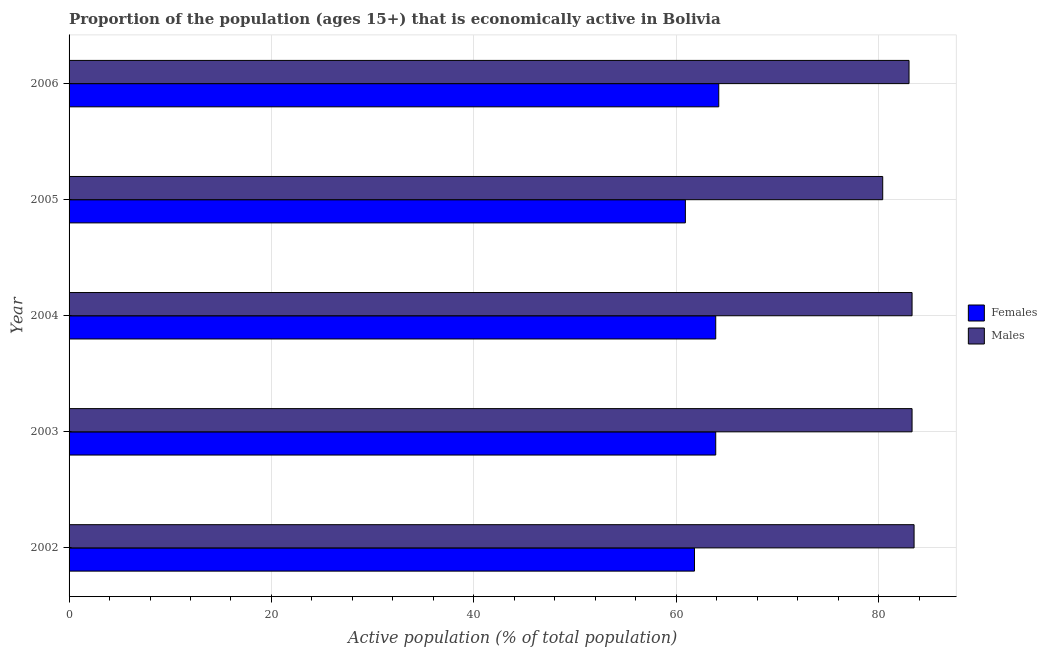How many groups of bars are there?
Provide a short and direct response. 5. What is the percentage of economically active female population in 2005?
Give a very brief answer. 60.9. Across all years, what is the maximum percentage of economically active male population?
Make the answer very short. 83.5. Across all years, what is the minimum percentage of economically active male population?
Your response must be concise. 80.4. In which year was the percentage of economically active male population maximum?
Provide a succinct answer. 2002. In which year was the percentage of economically active female population minimum?
Provide a short and direct response. 2005. What is the total percentage of economically active female population in the graph?
Ensure brevity in your answer.  314.7. What is the difference between the percentage of economically active male population in 2002 and that in 2003?
Your answer should be compact. 0.2. What is the difference between the percentage of economically active male population in 2002 and the percentage of economically active female population in 2003?
Offer a very short reply. 19.6. What is the average percentage of economically active male population per year?
Provide a short and direct response. 82.7. Is the percentage of economically active female population in 2002 less than that in 2004?
Provide a short and direct response. Yes. Is the difference between the percentage of economically active female population in 2002 and 2006 greater than the difference between the percentage of economically active male population in 2002 and 2006?
Provide a short and direct response. No. What is the difference between the highest and the second highest percentage of economically active male population?
Give a very brief answer. 0.2. In how many years, is the percentage of economically active female population greater than the average percentage of economically active female population taken over all years?
Make the answer very short. 3. What does the 1st bar from the top in 2004 represents?
Make the answer very short. Males. What does the 1st bar from the bottom in 2004 represents?
Your answer should be very brief. Females. How many bars are there?
Make the answer very short. 10. Are all the bars in the graph horizontal?
Your answer should be very brief. Yes. How many years are there in the graph?
Offer a terse response. 5. Does the graph contain any zero values?
Give a very brief answer. No. Does the graph contain grids?
Give a very brief answer. Yes. Where does the legend appear in the graph?
Your answer should be compact. Center right. How many legend labels are there?
Ensure brevity in your answer.  2. What is the title of the graph?
Offer a terse response. Proportion of the population (ages 15+) that is economically active in Bolivia. Does "Goods" appear as one of the legend labels in the graph?
Keep it short and to the point. No. What is the label or title of the X-axis?
Keep it short and to the point. Active population (% of total population). What is the Active population (% of total population) in Females in 2002?
Give a very brief answer. 61.8. What is the Active population (% of total population) of Males in 2002?
Make the answer very short. 83.5. What is the Active population (% of total population) in Females in 2003?
Your response must be concise. 63.9. What is the Active population (% of total population) of Males in 2003?
Provide a short and direct response. 83.3. What is the Active population (% of total population) in Females in 2004?
Give a very brief answer. 63.9. What is the Active population (% of total population) in Males in 2004?
Your answer should be compact. 83.3. What is the Active population (% of total population) of Females in 2005?
Make the answer very short. 60.9. What is the Active population (% of total population) in Males in 2005?
Your response must be concise. 80.4. What is the Active population (% of total population) of Females in 2006?
Keep it short and to the point. 64.2. Across all years, what is the maximum Active population (% of total population) of Females?
Your answer should be compact. 64.2. Across all years, what is the maximum Active population (% of total population) in Males?
Provide a succinct answer. 83.5. Across all years, what is the minimum Active population (% of total population) of Females?
Keep it short and to the point. 60.9. Across all years, what is the minimum Active population (% of total population) in Males?
Your answer should be very brief. 80.4. What is the total Active population (% of total population) in Females in the graph?
Offer a very short reply. 314.7. What is the total Active population (% of total population) of Males in the graph?
Ensure brevity in your answer.  413.5. What is the difference between the Active population (% of total population) of Females in 2002 and that in 2003?
Make the answer very short. -2.1. What is the difference between the Active population (% of total population) of Males in 2002 and that in 2003?
Give a very brief answer. 0.2. What is the difference between the Active population (% of total population) in Females in 2002 and that in 2004?
Ensure brevity in your answer.  -2.1. What is the difference between the Active population (% of total population) of Males in 2002 and that in 2004?
Your response must be concise. 0.2. What is the difference between the Active population (% of total population) of Females in 2002 and that in 2005?
Ensure brevity in your answer.  0.9. What is the difference between the Active population (% of total population) in Males in 2002 and that in 2005?
Your answer should be very brief. 3.1. What is the difference between the Active population (% of total population) in Females in 2002 and that in 2006?
Offer a terse response. -2.4. What is the difference between the Active population (% of total population) of Females in 2003 and that in 2005?
Make the answer very short. 3. What is the difference between the Active population (% of total population) in Females in 2004 and that in 2005?
Your answer should be compact. 3. What is the difference between the Active population (% of total population) of Males in 2004 and that in 2006?
Make the answer very short. 0.3. What is the difference between the Active population (% of total population) in Females in 2002 and the Active population (% of total population) in Males in 2003?
Ensure brevity in your answer.  -21.5. What is the difference between the Active population (% of total population) of Females in 2002 and the Active population (% of total population) of Males in 2004?
Give a very brief answer. -21.5. What is the difference between the Active population (% of total population) in Females in 2002 and the Active population (% of total population) in Males in 2005?
Your answer should be compact. -18.6. What is the difference between the Active population (% of total population) of Females in 2002 and the Active population (% of total population) of Males in 2006?
Provide a short and direct response. -21.2. What is the difference between the Active population (% of total population) of Females in 2003 and the Active population (% of total population) of Males in 2004?
Your answer should be very brief. -19.4. What is the difference between the Active population (% of total population) in Females in 2003 and the Active population (% of total population) in Males in 2005?
Provide a succinct answer. -16.5. What is the difference between the Active population (% of total population) of Females in 2003 and the Active population (% of total population) of Males in 2006?
Your answer should be compact. -19.1. What is the difference between the Active population (% of total population) of Females in 2004 and the Active population (% of total population) of Males in 2005?
Offer a very short reply. -16.5. What is the difference between the Active population (% of total population) in Females in 2004 and the Active population (% of total population) in Males in 2006?
Your answer should be very brief. -19.1. What is the difference between the Active population (% of total population) of Females in 2005 and the Active population (% of total population) of Males in 2006?
Offer a terse response. -22.1. What is the average Active population (% of total population) of Females per year?
Your answer should be compact. 62.94. What is the average Active population (% of total population) in Males per year?
Provide a short and direct response. 82.7. In the year 2002, what is the difference between the Active population (% of total population) in Females and Active population (% of total population) in Males?
Provide a succinct answer. -21.7. In the year 2003, what is the difference between the Active population (% of total population) of Females and Active population (% of total population) of Males?
Give a very brief answer. -19.4. In the year 2004, what is the difference between the Active population (% of total population) of Females and Active population (% of total population) of Males?
Your response must be concise. -19.4. In the year 2005, what is the difference between the Active population (% of total population) in Females and Active population (% of total population) in Males?
Ensure brevity in your answer.  -19.5. In the year 2006, what is the difference between the Active population (% of total population) in Females and Active population (% of total population) in Males?
Offer a terse response. -18.8. What is the ratio of the Active population (% of total population) in Females in 2002 to that in 2003?
Provide a short and direct response. 0.97. What is the ratio of the Active population (% of total population) in Females in 2002 to that in 2004?
Your answer should be compact. 0.97. What is the ratio of the Active population (% of total population) of Females in 2002 to that in 2005?
Your response must be concise. 1.01. What is the ratio of the Active population (% of total population) of Males in 2002 to that in 2005?
Your answer should be very brief. 1.04. What is the ratio of the Active population (% of total population) of Females in 2002 to that in 2006?
Provide a succinct answer. 0.96. What is the ratio of the Active population (% of total population) of Females in 2003 to that in 2004?
Provide a succinct answer. 1. What is the ratio of the Active population (% of total population) of Males in 2003 to that in 2004?
Offer a very short reply. 1. What is the ratio of the Active population (% of total population) in Females in 2003 to that in 2005?
Provide a succinct answer. 1.05. What is the ratio of the Active population (% of total population) of Males in 2003 to that in 2005?
Your answer should be very brief. 1.04. What is the ratio of the Active population (% of total population) of Males in 2003 to that in 2006?
Provide a short and direct response. 1. What is the ratio of the Active population (% of total population) of Females in 2004 to that in 2005?
Give a very brief answer. 1.05. What is the ratio of the Active population (% of total population) of Males in 2004 to that in 2005?
Offer a terse response. 1.04. What is the ratio of the Active population (% of total population) of Females in 2004 to that in 2006?
Your response must be concise. 1. What is the ratio of the Active population (% of total population) of Females in 2005 to that in 2006?
Your answer should be compact. 0.95. What is the ratio of the Active population (% of total population) of Males in 2005 to that in 2006?
Keep it short and to the point. 0.97. What is the difference between the highest and the second highest Active population (% of total population) in Females?
Offer a very short reply. 0.3. What is the difference between the highest and the second highest Active population (% of total population) of Males?
Your answer should be very brief. 0.2. What is the difference between the highest and the lowest Active population (% of total population) of Females?
Your response must be concise. 3.3. What is the difference between the highest and the lowest Active population (% of total population) in Males?
Provide a succinct answer. 3.1. 